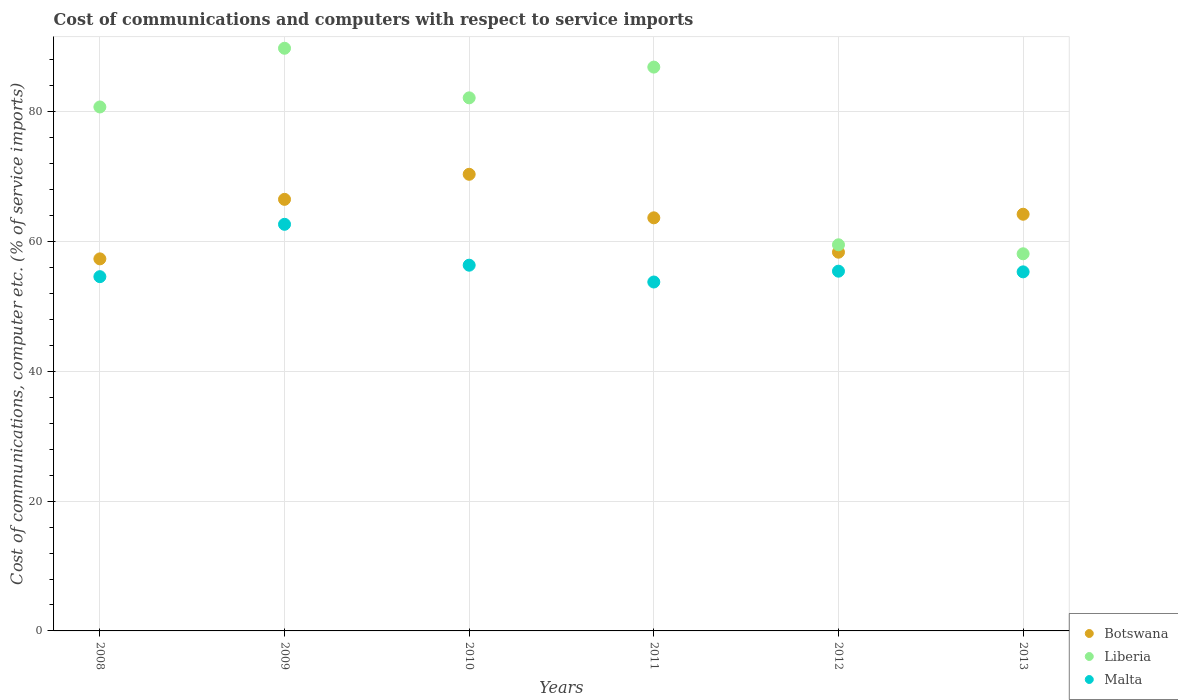How many different coloured dotlines are there?
Provide a short and direct response. 3. Is the number of dotlines equal to the number of legend labels?
Your answer should be very brief. Yes. What is the cost of communications and computers in Liberia in 2013?
Ensure brevity in your answer.  58.12. Across all years, what is the maximum cost of communications and computers in Liberia?
Ensure brevity in your answer.  89.79. Across all years, what is the minimum cost of communications and computers in Malta?
Give a very brief answer. 53.77. In which year was the cost of communications and computers in Liberia maximum?
Ensure brevity in your answer.  2009. In which year was the cost of communications and computers in Botswana minimum?
Your response must be concise. 2008. What is the total cost of communications and computers in Liberia in the graph?
Your answer should be very brief. 457.2. What is the difference between the cost of communications and computers in Malta in 2010 and that in 2013?
Your response must be concise. 1.03. What is the difference between the cost of communications and computers in Botswana in 2011 and the cost of communications and computers in Malta in 2013?
Provide a succinct answer. 8.33. What is the average cost of communications and computers in Botswana per year?
Offer a very short reply. 63.41. In the year 2010, what is the difference between the cost of communications and computers in Malta and cost of communications and computers in Liberia?
Keep it short and to the point. -25.79. In how many years, is the cost of communications and computers in Botswana greater than 68 %?
Provide a succinct answer. 1. What is the ratio of the cost of communications and computers in Malta in 2010 to that in 2013?
Make the answer very short. 1.02. Is the cost of communications and computers in Liberia in 2008 less than that in 2009?
Your response must be concise. Yes. What is the difference between the highest and the second highest cost of communications and computers in Botswana?
Provide a succinct answer. 3.86. What is the difference between the highest and the lowest cost of communications and computers in Liberia?
Your answer should be very brief. 31.67. Is the sum of the cost of communications and computers in Botswana in 2010 and 2011 greater than the maximum cost of communications and computers in Malta across all years?
Your answer should be compact. Yes. Does the cost of communications and computers in Malta monotonically increase over the years?
Your answer should be compact. No. Is the cost of communications and computers in Malta strictly greater than the cost of communications and computers in Liberia over the years?
Give a very brief answer. No. How many years are there in the graph?
Keep it short and to the point. 6. What is the difference between two consecutive major ticks on the Y-axis?
Your answer should be very brief. 20. Does the graph contain any zero values?
Give a very brief answer. No. Where does the legend appear in the graph?
Offer a terse response. Bottom right. How many legend labels are there?
Give a very brief answer. 3. What is the title of the graph?
Offer a terse response. Cost of communications and computers with respect to service imports. Does "Curacao" appear as one of the legend labels in the graph?
Keep it short and to the point. No. What is the label or title of the X-axis?
Make the answer very short. Years. What is the label or title of the Y-axis?
Make the answer very short. Cost of communications, computer etc. (% of service imports). What is the Cost of communications, computer etc. (% of service imports) of Botswana in 2008?
Offer a terse response. 57.34. What is the Cost of communications, computer etc. (% of service imports) of Liberia in 2008?
Your answer should be very brief. 80.74. What is the Cost of communications, computer etc. (% of service imports) in Malta in 2008?
Your response must be concise. 54.59. What is the Cost of communications, computer etc. (% of service imports) of Botswana in 2009?
Make the answer very short. 66.51. What is the Cost of communications, computer etc. (% of service imports) of Liberia in 2009?
Give a very brief answer. 89.79. What is the Cost of communications, computer etc. (% of service imports) of Malta in 2009?
Give a very brief answer. 62.66. What is the Cost of communications, computer etc. (% of service imports) in Botswana in 2010?
Offer a very short reply. 70.37. What is the Cost of communications, computer etc. (% of service imports) in Liberia in 2010?
Make the answer very short. 82.15. What is the Cost of communications, computer etc. (% of service imports) in Malta in 2010?
Give a very brief answer. 56.36. What is the Cost of communications, computer etc. (% of service imports) in Botswana in 2011?
Provide a short and direct response. 63.66. What is the Cost of communications, computer etc. (% of service imports) in Liberia in 2011?
Your response must be concise. 86.89. What is the Cost of communications, computer etc. (% of service imports) of Malta in 2011?
Keep it short and to the point. 53.77. What is the Cost of communications, computer etc. (% of service imports) of Botswana in 2012?
Offer a very short reply. 58.36. What is the Cost of communications, computer etc. (% of service imports) in Liberia in 2012?
Your answer should be very brief. 59.51. What is the Cost of communications, computer etc. (% of service imports) of Malta in 2012?
Your answer should be very brief. 55.44. What is the Cost of communications, computer etc. (% of service imports) of Botswana in 2013?
Offer a terse response. 64.21. What is the Cost of communications, computer etc. (% of service imports) of Liberia in 2013?
Ensure brevity in your answer.  58.12. What is the Cost of communications, computer etc. (% of service imports) in Malta in 2013?
Offer a terse response. 55.33. Across all years, what is the maximum Cost of communications, computer etc. (% of service imports) in Botswana?
Your response must be concise. 70.37. Across all years, what is the maximum Cost of communications, computer etc. (% of service imports) in Liberia?
Your response must be concise. 89.79. Across all years, what is the maximum Cost of communications, computer etc. (% of service imports) of Malta?
Your answer should be compact. 62.66. Across all years, what is the minimum Cost of communications, computer etc. (% of service imports) in Botswana?
Provide a succinct answer. 57.34. Across all years, what is the minimum Cost of communications, computer etc. (% of service imports) in Liberia?
Ensure brevity in your answer.  58.12. Across all years, what is the minimum Cost of communications, computer etc. (% of service imports) of Malta?
Your response must be concise. 53.77. What is the total Cost of communications, computer etc. (% of service imports) in Botswana in the graph?
Make the answer very short. 380.45. What is the total Cost of communications, computer etc. (% of service imports) in Liberia in the graph?
Your response must be concise. 457.2. What is the total Cost of communications, computer etc. (% of service imports) in Malta in the graph?
Your answer should be very brief. 338.16. What is the difference between the Cost of communications, computer etc. (% of service imports) in Botswana in 2008 and that in 2009?
Provide a succinct answer. -9.17. What is the difference between the Cost of communications, computer etc. (% of service imports) in Liberia in 2008 and that in 2009?
Make the answer very short. -9.05. What is the difference between the Cost of communications, computer etc. (% of service imports) in Malta in 2008 and that in 2009?
Provide a short and direct response. -8.07. What is the difference between the Cost of communications, computer etc. (% of service imports) of Botswana in 2008 and that in 2010?
Offer a very short reply. -13.03. What is the difference between the Cost of communications, computer etc. (% of service imports) of Liberia in 2008 and that in 2010?
Provide a succinct answer. -1.41. What is the difference between the Cost of communications, computer etc. (% of service imports) in Malta in 2008 and that in 2010?
Your answer should be very brief. -1.77. What is the difference between the Cost of communications, computer etc. (% of service imports) of Botswana in 2008 and that in 2011?
Your response must be concise. -6.32. What is the difference between the Cost of communications, computer etc. (% of service imports) of Liberia in 2008 and that in 2011?
Provide a short and direct response. -6.14. What is the difference between the Cost of communications, computer etc. (% of service imports) of Malta in 2008 and that in 2011?
Provide a short and direct response. 0.82. What is the difference between the Cost of communications, computer etc. (% of service imports) in Botswana in 2008 and that in 2012?
Make the answer very short. -1.03. What is the difference between the Cost of communications, computer etc. (% of service imports) in Liberia in 2008 and that in 2012?
Your response must be concise. 21.24. What is the difference between the Cost of communications, computer etc. (% of service imports) of Malta in 2008 and that in 2012?
Provide a short and direct response. -0.85. What is the difference between the Cost of communications, computer etc. (% of service imports) of Botswana in 2008 and that in 2013?
Give a very brief answer. -6.88. What is the difference between the Cost of communications, computer etc. (% of service imports) of Liberia in 2008 and that in 2013?
Provide a succinct answer. 22.63. What is the difference between the Cost of communications, computer etc. (% of service imports) of Malta in 2008 and that in 2013?
Keep it short and to the point. -0.74. What is the difference between the Cost of communications, computer etc. (% of service imports) of Botswana in 2009 and that in 2010?
Make the answer very short. -3.86. What is the difference between the Cost of communications, computer etc. (% of service imports) of Liberia in 2009 and that in 2010?
Your answer should be very brief. 7.64. What is the difference between the Cost of communications, computer etc. (% of service imports) in Malta in 2009 and that in 2010?
Ensure brevity in your answer.  6.3. What is the difference between the Cost of communications, computer etc. (% of service imports) in Botswana in 2009 and that in 2011?
Provide a succinct answer. 2.85. What is the difference between the Cost of communications, computer etc. (% of service imports) of Liberia in 2009 and that in 2011?
Provide a short and direct response. 2.9. What is the difference between the Cost of communications, computer etc. (% of service imports) of Malta in 2009 and that in 2011?
Your response must be concise. 8.89. What is the difference between the Cost of communications, computer etc. (% of service imports) of Botswana in 2009 and that in 2012?
Offer a terse response. 8.15. What is the difference between the Cost of communications, computer etc. (% of service imports) of Liberia in 2009 and that in 2012?
Make the answer very short. 30.29. What is the difference between the Cost of communications, computer etc. (% of service imports) of Malta in 2009 and that in 2012?
Give a very brief answer. 7.22. What is the difference between the Cost of communications, computer etc. (% of service imports) in Botswana in 2009 and that in 2013?
Provide a succinct answer. 2.29. What is the difference between the Cost of communications, computer etc. (% of service imports) in Liberia in 2009 and that in 2013?
Your answer should be compact. 31.67. What is the difference between the Cost of communications, computer etc. (% of service imports) in Malta in 2009 and that in 2013?
Your response must be concise. 7.33. What is the difference between the Cost of communications, computer etc. (% of service imports) in Botswana in 2010 and that in 2011?
Make the answer very short. 6.71. What is the difference between the Cost of communications, computer etc. (% of service imports) of Liberia in 2010 and that in 2011?
Your response must be concise. -4.74. What is the difference between the Cost of communications, computer etc. (% of service imports) in Malta in 2010 and that in 2011?
Your response must be concise. 2.59. What is the difference between the Cost of communications, computer etc. (% of service imports) of Botswana in 2010 and that in 2012?
Offer a terse response. 12.01. What is the difference between the Cost of communications, computer etc. (% of service imports) of Liberia in 2010 and that in 2012?
Your answer should be very brief. 22.64. What is the difference between the Cost of communications, computer etc. (% of service imports) in Malta in 2010 and that in 2012?
Make the answer very short. 0.92. What is the difference between the Cost of communications, computer etc. (% of service imports) of Botswana in 2010 and that in 2013?
Ensure brevity in your answer.  6.16. What is the difference between the Cost of communications, computer etc. (% of service imports) in Liberia in 2010 and that in 2013?
Your answer should be very brief. 24.03. What is the difference between the Cost of communications, computer etc. (% of service imports) of Malta in 2010 and that in 2013?
Give a very brief answer. 1.03. What is the difference between the Cost of communications, computer etc. (% of service imports) in Botswana in 2011 and that in 2012?
Make the answer very short. 5.3. What is the difference between the Cost of communications, computer etc. (% of service imports) in Liberia in 2011 and that in 2012?
Offer a terse response. 27.38. What is the difference between the Cost of communications, computer etc. (% of service imports) in Malta in 2011 and that in 2012?
Give a very brief answer. -1.67. What is the difference between the Cost of communications, computer etc. (% of service imports) in Botswana in 2011 and that in 2013?
Ensure brevity in your answer.  -0.55. What is the difference between the Cost of communications, computer etc. (% of service imports) of Liberia in 2011 and that in 2013?
Make the answer very short. 28.77. What is the difference between the Cost of communications, computer etc. (% of service imports) in Malta in 2011 and that in 2013?
Make the answer very short. -1.56. What is the difference between the Cost of communications, computer etc. (% of service imports) of Botswana in 2012 and that in 2013?
Keep it short and to the point. -5.85. What is the difference between the Cost of communications, computer etc. (% of service imports) in Liberia in 2012 and that in 2013?
Ensure brevity in your answer.  1.39. What is the difference between the Cost of communications, computer etc. (% of service imports) in Malta in 2012 and that in 2013?
Give a very brief answer. 0.11. What is the difference between the Cost of communications, computer etc. (% of service imports) of Botswana in 2008 and the Cost of communications, computer etc. (% of service imports) of Liberia in 2009?
Ensure brevity in your answer.  -32.46. What is the difference between the Cost of communications, computer etc. (% of service imports) in Botswana in 2008 and the Cost of communications, computer etc. (% of service imports) in Malta in 2009?
Your answer should be very brief. -5.33. What is the difference between the Cost of communications, computer etc. (% of service imports) in Liberia in 2008 and the Cost of communications, computer etc. (% of service imports) in Malta in 2009?
Your answer should be compact. 18.08. What is the difference between the Cost of communications, computer etc. (% of service imports) in Botswana in 2008 and the Cost of communications, computer etc. (% of service imports) in Liberia in 2010?
Your answer should be compact. -24.81. What is the difference between the Cost of communications, computer etc. (% of service imports) of Botswana in 2008 and the Cost of communications, computer etc. (% of service imports) of Malta in 2010?
Provide a short and direct response. 0.97. What is the difference between the Cost of communications, computer etc. (% of service imports) in Liberia in 2008 and the Cost of communications, computer etc. (% of service imports) in Malta in 2010?
Keep it short and to the point. 24.38. What is the difference between the Cost of communications, computer etc. (% of service imports) of Botswana in 2008 and the Cost of communications, computer etc. (% of service imports) of Liberia in 2011?
Keep it short and to the point. -29.55. What is the difference between the Cost of communications, computer etc. (% of service imports) of Botswana in 2008 and the Cost of communications, computer etc. (% of service imports) of Malta in 2011?
Offer a very short reply. 3.57. What is the difference between the Cost of communications, computer etc. (% of service imports) of Liberia in 2008 and the Cost of communications, computer etc. (% of service imports) of Malta in 2011?
Your answer should be very brief. 26.97. What is the difference between the Cost of communications, computer etc. (% of service imports) in Botswana in 2008 and the Cost of communications, computer etc. (% of service imports) in Liberia in 2012?
Provide a short and direct response. -2.17. What is the difference between the Cost of communications, computer etc. (% of service imports) in Botswana in 2008 and the Cost of communications, computer etc. (% of service imports) in Malta in 2012?
Make the answer very short. 1.9. What is the difference between the Cost of communications, computer etc. (% of service imports) of Liberia in 2008 and the Cost of communications, computer etc. (% of service imports) of Malta in 2012?
Make the answer very short. 25.31. What is the difference between the Cost of communications, computer etc. (% of service imports) in Botswana in 2008 and the Cost of communications, computer etc. (% of service imports) in Liberia in 2013?
Your answer should be compact. -0.78. What is the difference between the Cost of communications, computer etc. (% of service imports) in Botswana in 2008 and the Cost of communications, computer etc. (% of service imports) in Malta in 2013?
Your answer should be compact. 2. What is the difference between the Cost of communications, computer etc. (% of service imports) of Liberia in 2008 and the Cost of communications, computer etc. (% of service imports) of Malta in 2013?
Make the answer very short. 25.41. What is the difference between the Cost of communications, computer etc. (% of service imports) of Botswana in 2009 and the Cost of communications, computer etc. (% of service imports) of Liberia in 2010?
Provide a succinct answer. -15.64. What is the difference between the Cost of communications, computer etc. (% of service imports) of Botswana in 2009 and the Cost of communications, computer etc. (% of service imports) of Malta in 2010?
Ensure brevity in your answer.  10.15. What is the difference between the Cost of communications, computer etc. (% of service imports) in Liberia in 2009 and the Cost of communications, computer etc. (% of service imports) in Malta in 2010?
Keep it short and to the point. 33.43. What is the difference between the Cost of communications, computer etc. (% of service imports) in Botswana in 2009 and the Cost of communications, computer etc. (% of service imports) in Liberia in 2011?
Provide a short and direct response. -20.38. What is the difference between the Cost of communications, computer etc. (% of service imports) of Botswana in 2009 and the Cost of communications, computer etc. (% of service imports) of Malta in 2011?
Provide a short and direct response. 12.74. What is the difference between the Cost of communications, computer etc. (% of service imports) of Liberia in 2009 and the Cost of communications, computer etc. (% of service imports) of Malta in 2011?
Provide a short and direct response. 36.02. What is the difference between the Cost of communications, computer etc. (% of service imports) in Botswana in 2009 and the Cost of communications, computer etc. (% of service imports) in Liberia in 2012?
Provide a succinct answer. 7. What is the difference between the Cost of communications, computer etc. (% of service imports) of Botswana in 2009 and the Cost of communications, computer etc. (% of service imports) of Malta in 2012?
Your answer should be very brief. 11.07. What is the difference between the Cost of communications, computer etc. (% of service imports) in Liberia in 2009 and the Cost of communications, computer etc. (% of service imports) in Malta in 2012?
Your answer should be compact. 34.35. What is the difference between the Cost of communications, computer etc. (% of service imports) in Botswana in 2009 and the Cost of communications, computer etc. (% of service imports) in Liberia in 2013?
Offer a very short reply. 8.39. What is the difference between the Cost of communications, computer etc. (% of service imports) in Botswana in 2009 and the Cost of communications, computer etc. (% of service imports) in Malta in 2013?
Your answer should be very brief. 11.17. What is the difference between the Cost of communications, computer etc. (% of service imports) in Liberia in 2009 and the Cost of communications, computer etc. (% of service imports) in Malta in 2013?
Give a very brief answer. 34.46. What is the difference between the Cost of communications, computer etc. (% of service imports) in Botswana in 2010 and the Cost of communications, computer etc. (% of service imports) in Liberia in 2011?
Offer a very short reply. -16.52. What is the difference between the Cost of communications, computer etc. (% of service imports) of Botswana in 2010 and the Cost of communications, computer etc. (% of service imports) of Malta in 2011?
Make the answer very short. 16.6. What is the difference between the Cost of communications, computer etc. (% of service imports) of Liberia in 2010 and the Cost of communications, computer etc. (% of service imports) of Malta in 2011?
Your answer should be very brief. 28.38. What is the difference between the Cost of communications, computer etc. (% of service imports) of Botswana in 2010 and the Cost of communications, computer etc. (% of service imports) of Liberia in 2012?
Offer a very short reply. 10.86. What is the difference between the Cost of communications, computer etc. (% of service imports) of Botswana in 2010 and the Cost of communications, computer etc. (% of service imports) of Malta in 2012?
Keep it short and to the point. 14.93. What is the difference between the Cost of communications, computer etc. (% of service imports) of Liberia in 2010 and the Cost of communications, computer etc. (% of service imports) of Malta in 2012?
Give a very brief answer. 26.71. What is the difference between the Cost of communications, computer etc. (% of service imports) in Botswana in 2010 and the Cost of communications, computer etc. (% of service imports) in Liberia in 2013?
Provide a succinct answer. 12.25. What is the difference between the Cost of communications, computer etc. (% of service imports) in Botswana in 2010 and the Cost of communications, computer etc. (% of service imports) in Malta in 2013?
Give a very brief answer. 15.04. What is the difference between the Cost of communications, computer etc. (% of service imports) in Liberia in 2010 and the Cost of communications, computer etc. (% of service imports) in Malta in 2013?
Provide a short and direct response. 26.82. What is the difference between the Cost of communications, computer etc. (% of service imports) in Botswana in 2011 and the Cost of communications, computer etc. (% of service imports) in Liberia in 2012?
Your answer should be very brief. 4.15. What is the difference between the Cost of communications, computer etc. (% of service imports) of Botswana in 2011 and the Cost of communications, computer etc. (% of service imports) of Malta in 2012?
Provide a short and direct response. 8.22. What is the difference between the Cost of communications, computer etc. (% of service imports) in Liberia in 2011 and the Cost of communications, computer etc. (% of service imports) in Malta in 2012?
Offer a terse response. 31.45. What is the difference between the Cost of communications, computer etc. (% of service imports) in Botswana in 2011 and the Cost of communications, computer etc. (% of service imports) in Liberia in 2013?
Your response must be concise. 5.54. What is the difference between the Cost of communications, computer etc. (% of service imports) in Botswana in 2011 and the Cost of communications, computer etc. (% of service imports) in Malta in 2013?
Keep it short and to the point. 8.33. What is the difference between the Cost of communications, computer etc. (% of service imports) of Liberia in 2011 and the Cost of communications, computer etc. (% of service imports) of Malta in 2013?
Your answer should be very brief. 31.55. What is the difference between the Cost of communications, computer etc. (% of service imports) in Botswana in 2012 and the Cost of communications, computer etc. (% of service imports) in Liberia in 2013?
Ensure brevity in your answer.  0.24. What is the difference between the Cost of communications, computer etc. (% of service imports) of Botswana in 2012 and the Cost of communications, computer etc. (% of service imports) of Malta in 2013?
Offer a terse response. 3.03. What is the difference between the Cost of communications, computer etc. (% of service imports) in Liberia in 2012 and the Cost of communications, computer etc. (% of service imports) in Malta in 2013?
Offer a terse response. 4.17. What is the average Cost of communications, computer etc. (% of service imports) in Botswana per year?
Provide a short and direct response. 63.41. What is the average Cost of communications, computer etc. (% of service imports) of Liberia per year?
Your answer should be compact. 76.2. What is the average Cost of communications, computer etc. (% of service imports) in Malta per year?
Give a very brief answer. 56.36. In the year 2008, what is the difference between the Cost of communications, computer etc. (% of service imports) in Botswana and Cost of communications, computer etc. (% of service imports) in Liberia?
Make the answer very short. -23.41. In the year 2008, what is the difference between the Cost of communications, computer etc. (% of service imports) in Botswana and Cost of communications, computer etc. (% of service imports) in Malta?
Keep it short and to the point. 2.74. In the year 2008, what is the difference between the Cost of communications, computer etc. (% of service imports) of Liberia and Cost of communications, computer etc. (% of service imports) of Malta?
Keep it short and to the point. 26.15. In the year 2009, what is the difference between the Cost of communications, computer etc. (% of service imports) in Botswana and Cost of communications, computer etc. (% of service imports) in Liberia?
Your response must be concise. -23.28. In the year 2009, what is the difference between the Cost of communications, computer etc. (% of service imports) in Botswana and Cost of communications, computer etc. (% of service imports) in Malta?
Provide a succinct answer. 3.85. In the year 2009, what is the difference between the Cost of communications, computer etc. (% of service imports) of Liberia and Cost of communications, computer etc. (% of service imports) of Malta?
Provide a succinct answer. 27.13. In the year 2010, what is the difference between the Cost of communications, computer etc. (% of service imports) of Botswana and Cost of communications, computer etc. (% of service imports) of Liberia?
Your answer should be very brief. -11.78. In the year 2010, what is the difference between the Cost of communications, computer etc. (% of service imports) in Botswana and Cost of communications, computer etc. (% of service imports) in Malta?
Offer a terse response. 14.01. In the year 2010, what is the difference between the Cost of communications, computer etc. (% of service imports) in Liberia and Cost of communications, computer etc. (% of service imports) in Malta?
Offer a terse response. 25.79. In the year 2011, what is the difference between the Cost of communications, computer etc. (% of service imports) of Botswana and Cost of communications, computer etc. (% of service imports) of Liberia?
Offer a terse response. -23.23. In the year 2011, what is the difference between the Cost of communications, computer etc. (% of service imports) of Botswana and Cost of communications, computer etc. (% of service imports) of Malta?
Your answer should be compact. 9.89. In the year 2011, what is the difference between the Cost of communications, computer etc. (% of service imports) of Liberia and Cost of communications, computer etc. (% of service imports) of Malta?
Offer a terse response. 33.12. In the year 2012, what is the difference between the Cost of communications, computer etc. (% of service imports) of Botswana and Cost of communications, computer etc. (% of service imports) of Liberia?
Ensure brevity in your answer.  -1.14. In the year 2012, what is the difference between the Cost of communications, computer etc. (% of service imports) in Botswana and Cost of communications, computer etc. (% of service imports) in Malta?
Your response must be concise. 2.92. In the year 2012, what is the difference between the Cost of communications, computer etc. (% of service imports) of Liberia and Cost of communications, computer etc. (% of service imports) of Malta?
Offer a terse response. 4.07. In the year 2013, what is the difference between the Cost of communications, computer etc. (% of service imports) in Botswana and Cost of communications, computer etc. (% of service imports) in Liberia?
Offer a very short reply. 6.09. In the year 2013, what is the difference between the Cost of communications, computer etc. (% of service imports) in Botswana and Cost of communications, computer etc. (% of service imports) in Malta?
Offer a very short reply. 8.88. In the year 2013, what is the difference between the Cost of communications, computer etc. (% of service imports) of Liberia and Cost of communications, computer etc. (% of service imports) of Malta?
Your answer should be compact. 2.79. What is the ratio of the Cost of communications, computer etc. (% of service imports) in Botswana in 2008 to that in 2009?
Your answer should be compact. 0.86. What is the ratio of the Cost of communications, computer etc. (% of service imports) of Liberia in 2008 to that in 2009?
Ensure brevity in your answer.  0.9. What is the ratio of the Cost of communications, computer etc. (% of service imports) in Malta in 2008 to that in 2009?
Your answer should be compact. 0.87. What is the ratio of the Cost of communications, computer etc. (% of service imports) of Botswana in 2008 to that in 2010?
Keep it short and to the point. 0.81. What is the ratio of the Cost of communications, computer etc. (% of service imports) of Liberia in 2008 to that in 2010?
Offer a terse response. 0.98. What is the ratio of the Cost of communications, computer etc. (% of service imports) of Malta in 2008 to that in 2010?
Provide a succinct answer. 0.97. What is the ratio of the Cost of communications, computer etc. (% of service imports) of Botswana in 2008 to that in 2011?
Offer a very short reply. 0.9. What is the ratio of the Cost of communications, computer etc. (% of service imports) of Liberia in 2008 to that in 2011?
Your answer should be very brief. 0.93. What is the ratio of the Cost of communications, computer etc. (% of service imports) of Malta in 2008 to that in 2011?
Offer a very short reply. 1.02. What is the ratio of the Cost of communications, computer etc. (% of service imports) of Botswana in 2008 to that in 2012?
Keep it short and to the point. 0.98. What is the ratio of the Cost of communications, computer etc. (% of service imports) in Liberia in 2008 to that in 2012?
Your answer should be very brief. 1.36. What is the ratio of the Cost of communications, computer etc. (% of service imports) of Malta in 2008 to that in 2012?
Ensure brevity in your answer.  0.98. What is the ratio of the Cost of communications, computer etc. (% of service imports) in Botswana in 2008 to that in 2013?
Keep it short and to the point. 0.89. What is the ratio of the Cost of communications, computer etc. (% of service imports) in Liberia in 2008 to that in 2013?
Ensure brevity in your answer.  1.39. What is the ratio of the Cost of communications, computer etc. (% of service imports) of Malta in 2008 to that in 2013?
Offer a terse response. 0.99. What is the ratio of the Cost of communications, computer etc. (% of service imports) in Botswana in 2009 to that in 2010?
Keep it short and to the point. 0.95. What is the ratio of the Cost of communications, computer etc. (% of service imports) of Liberia in 2009 to that in 2010?
Offer a very short reply. 1.09. What is the ratio of the Cost of communications, computer etc. (% of service imports) in Malta in 2009 to that in 2010?
Offer a very short reply. 1.11. What is the ratio of the Cost of communications, computer etc. (% of service imports) in Botswana in 2009 to that in 2011?
Your answer should be compact. 1.04. What is the ratio of the Cost of communications, computer etc. (% of service imports) in Liberia in 2009 to that in 2011?
Provide a succinct answer. 1.03. What is the ratio of the Cost of communications, computer etc. (% of service imports) of Malta in 2009 to that in 2011?
Your response must be concise. 1.17. What is the ratio of the Cost of communications, computer etc. (% of service imports) of Botswana in 2009 to that in 2012?
Give a very brief answer. 1.14. What is the ratio of the Cost of communications, computer etc. (% of service imports) of Liberia in 2009 to that in 2012?
Your answer should be very brief. 1.51. What is the ratio of the Cost of communications, computer etc. (% of service imports) of Malta in 2009 to that in 2012?
Your answer should be very brief. 1.13. What is the ratio of the Cost of communications, computer etc. (% of service imports) in Botswana in 2009 to that in 2013?
Provide a succinct answer. 1.04. What is the ratio of the Cost of communications, computer etc. (% of service imports) of Liberia in 2009 to that in 2013?
Offer a terse response. 1.54. What is the ratio of the Cost of communications, computer etc. (% of service imports) of Malta in 2009 to that in 2013?
Provide a succinct answer. 1.13. What is the ratio of the Cost of communications, computer etc. (% of service imports) in Botswana in 2010 to that in 2011?
Your response must be concise. 1.11. What is the ratio of the Cost of communications, computer etc. (% of service imports) in Liberia in 2010 to that in 2011?
Provide a short and direct response. 0.95. What is the ratio of the Cost of communications, computer etc. (% of service imports) of Malta in 2010 to that in 2011?
Keep it short and to the point. 1.05. What is the ratio of the Cost of communications, computer etc. (% of service imports) in Botswana in 2010 to that in 2012?
Offer a very short reply. 1.21. What is the ratio of the Cost of communications, computer etc. (% of service imports) in Liberia in 2010 to that in 2012?
Make the answer very short. 1.38. What is the ratio of the Cost of communications, computer etc. (% of service imports) in Malta in 2010 to that in 2012?
Your answer should be compact. 1.02. What is the ratio of the Cost of communications, computer etc. (% of service imports) in Botswana in 2010 to that in 2013?
Give a very brief answer. 1.1. What is the ratio of the Cost of communications, computer etc. (% of service imports) in Liberia in 2010 to that in 2013?
Keep it short and to the point. 1.41. What is the ratio of the Cost of communications, computer etc. (% of service imports) in Malta in 2010 to that in 2013?
Ensure brevity in your answer.  1.02. What is the ratio of the Cost of communications, computer etc. (% of service imports) of Botswana in 2011 to that in 2012?
Offer a terse response. 1.09. What is the ratio of the Cost of communications, computer etc. (% of service imports) in Liberia in 2011 to that in 2012?
Provide a short and direct response. 1.46. What is the ratio of the Cost of communications, computer etc. (% of service imports) of Malta in 2011 to that in 2012?
Provide a succinct answer. 0.97. What is the ratio of the Cost of communications, computer etc. (% of service imports) in Botswana in 2011 to that in 2013?
Keep it short and to the point. 0.99. What is the ratio of the Cost of communications, computer etc. (% of service imports) in Liberia in 2011 to that in 2013?
Offer a terse response. 1.5. What is the ratio of the Cost of communications, computer etc. (% of service imports) of Malta in 2011 to that in 2013?
Make the answer very short. 0.97. What is the ratio of the Cost of communications, computer etc. (% of service imports) of Botswana in 2012 to that in 2013?
Give a very brief answer. 0.91. What is the ratio of the Cost of communications, computer etc. (% of service imports) of Liberia in 2012 to that in 2013?
Offer a terse response. 1.02. What is the ratio of the Cost of communications, computer etc. (% of service imports) of Malta in 2012 to that in 2013?
Provide a succinct answer. 1. What is the difference between the highest and the second highest Cost of communications, computer etc. (% of service imports) in Botswana?
Your answer should be very brief. 3.86. What is the difference between the highest and the second highest Cost of communications, computer etc. (% of service imports) in Liberia?
Offer a very short reply. 2.9. What is the difference between the highest and the second highest Cost of communications, computer etc. (% of service imports) in Malta?
Make the answer very short. 6.3. What is the difference between the highest and the lowest Cost of communications, computer etc. (% of service imports) in Botswana?
Your answer should be very brief. 13.03. What is the difference between the highest and the lowest Cost of communications, computer etc. (% of service imports) in Liberia?
Make the answer very short. 31.67. What is the difference between the highest and the lowest Cost of communications, computer etc. (% of service imports) in Malta?
Provide a succinct answer. 8.89. 